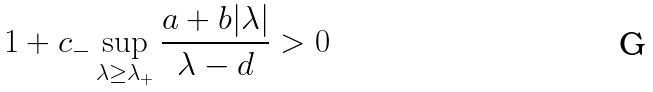<formula> <loc_0><loc_0><loc_500><loc_500>1 + c _ { - } \sup _ { \lambda \geq \lambda _ { + } } \frac { a + b | \lambda | } { \lambda - d } > 0</formula> 